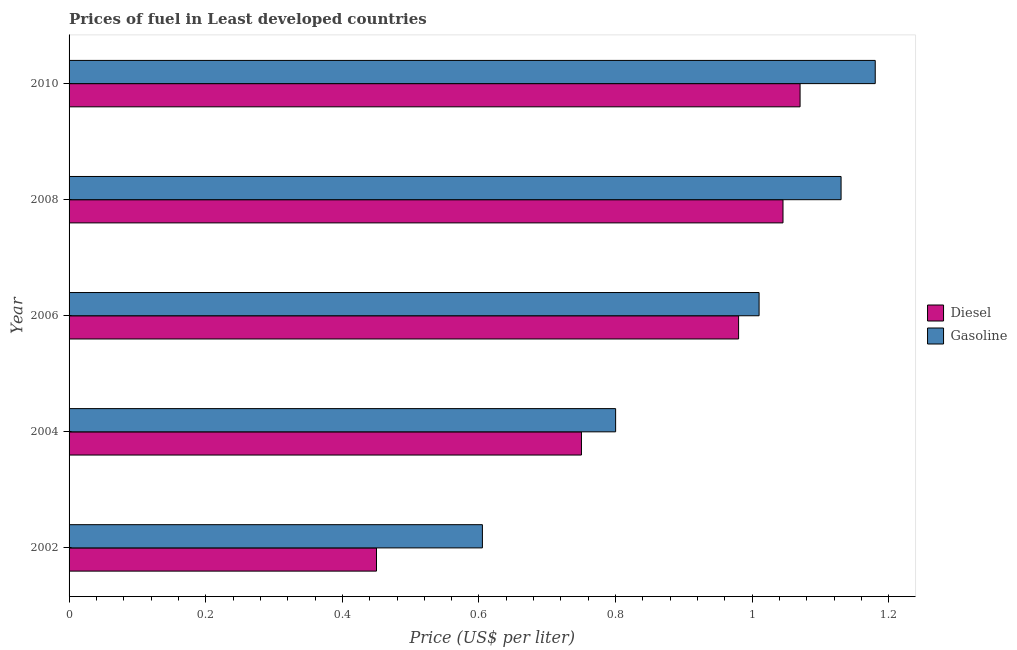How many different coloured bars are there?
Your answer should be compact. 2. How many groups of bars are there?
Your answer should be very brief. 5. How many bars are there on the 5th tick from the top?
Ensure brevity in your answer.  2. How many bars are there on the 5th tick from the bottom?
Your answer should be very brief. 2. In how many cases, is the number of bars for a given year not equal to the number of legend labels?
Make the answer very short. 0. What is the diesel price in 2006?
Provide a short and direct response. 0.98. Across all years, what is the maximum diesel price?
Provide a succinct answer. 1.07. Across all years, what is the minimum diesel price?
Ensure brevity in your answer.  0.45. In which year was the gasoline price maximum?
Your answer should be compact. 2010. In which year was the gasoline price minimum?
Give a very brief answer. 2002. What is the total gasoline price in the graph?
Your answer should be compact. 4.72. What is the difference between the gasoline price in 2004 and that in 2008?
Provide a succinct answer. -0.33. What is the difference between the diesel price in 2006 and the gasoline price in 2008?
Offer a terse response. -0.15. What is the average diesel price per year?
Keep it short and to the point. 0.86. What is the ratio of the gasoline price in 2002 to that in 2006?
Make the answer very short. 0.6. Is the gasoline price in 2002 less than that in 2010?
Make the answer very short. Yes. Is the difference between the gasoline price in 2002 and 2008 greater than the difference between the diesel price in 2002 and 2008?
Your answer should be compact. Yes. What is the difference between the highest and the second highest diesel price?
Provide a short and direct response. 0.03. What is the difference between the highest and the lowest gasoline price?
Make the answer very short. 0.57. Is the sum of the gasoline price in 2002 and 2004 greater than the maximum diesel price across all years?
Your response must be concise. Yes. What does the 1st bar from the top in 2004 represents?
Your answer should be compact. Gasoline. What does the 2nd bar from the bottom in 2006 represents?
Make the answer very short. Gasoline. Are all the bars in the graph horizontal?
Offer a very short reply. Yes. How many years are there in the graph?
Keep it short and to the point. 5. Are the values on the major ticks of X-axis written in scientific E-notation?
Give a very brief answer. No. What is the title of the graph?
Your response must be concise. Prices of fuel in Least developed countries. What is the label or title of the X-axis?
Your answer should be compact. Price (US$ per liter). What is the Price (US$ per liter) of Diesel in 2002?
Ensure brevity in your answer.  0.45. What is the Price (US$ per liter) in Gasoline in 2002?
Give a very brief answer. 0.6. What is the Price (US$ per liter) of Diesel in 2004?
Your answer should be compact. 0.75. What is the Price (US$ per liter) in Gasoline in 2004?
Make the answer very short. 0.8. What is the Price (US$ per liter) in Diesel in 2006?
Offer a very short reply. 0.98. What is the Price (US$ per liter) of Diesel in 2008?
Ensure brevity in your answer.  1.04. What is the Price (US$ per liter) in Gasoline in 2008?
Your answer should be compact. 1.13. What is the Price (US$ per liter) in Diesel in 2010?
Keep it short and to the point. 1.07. What is the Price (US$ per liter) of Gasoline in 2010?
Give a very brief answer. 1.18. Across all years, what is the maximum Price (US$ per liter) of Diesel?
Ensure brevity in your answer.  1.07. Across all years, what is the maximum Price (US$ per liter) of Gasoline?
Make the answer very short. 1.18. Across all years, what is the minimum Price (US$ per liter) in Diesel?
Offer a terse response. 0.45. Across all years, what is the minimum Price (US$ per liter) in Gasoline?
Make the answer very short. 0.6. What is the total Price (US$ per liter) in Diesel in the graph?
Your answer should be very brief. 4.29. What is the total Price (US$ per liter) in Gasoline in the graph?
Your answer should be compact. 4.72. What is the difference between the Price (US$ per liter) in Diesel in 2002 and that in 2004?
Give a very brief answer. -0.3. What is the difference between the Price (US$ per liter) of Gasoline in 2002 and that in 2004?
Your answer should be compact. -0.2. What is the difference between the Price (US$ per liter) in Diesel in 2002 and that in 2006?
Offer a terse response. -0.53. What is the difference between the Price (US$ per liter) in Gasoline in 2002 and that in 2006?
Make the answer very short. -0.41. What is the difference between the Price (US$ per liter) of Diesel in 2002 and that in 2008?
Make the answer very short. -0.59. What is the difference between the Price (US$ per liter) of Gasoline in 2002 and that in 2008?
Give a very brief answer. -0.53. What is the difference between the Price (US$ per liter) of Diesel in 2002 and that in 2010?
Make the answer very short. -0.62. What is the difference between the Price (US$ per liter) in Gasoline in 2002 and that in 2010?
Provide a short and direct response. -0.57. What is the difference between the Price (US$ per liter) in Diesel in 2004 and that in 2006?
Your answer should be compact. -0.23. What is the difference between the Price (US$ per liter) of Gasoline in 2004 and that in 2006?
Offer a very short reply. -0.21. What is the difference between the Price (US$ per liter) in Diesel in 2004 and that in 2008?
Provide a short and direct response. -0.29. What is the difference between the Price (US$ per liter) of Gasoline in 2004 and that in 2008?
Give a very brief answer. -0.33. What is the difference between the Price (US$ per liter) in Diesel in 2004 and that in 2010?
Your answer should be compact. -0.32. What is the difference between the Price (US$ per liter) in Gasoline in 2004 and that in 2010?
Your answer should be very brief. -0.38. What is the difference between the Price (US$ per liter) of Diesel in 2006 and that in 2008?
Your answer should be very brief. -0.07. What is the difference between the Price (US$ per liter) of Gasoline in 2006 and that in 2008?
Your answer should be very brief. -0.12. What is the difference between the Price (US$ per liter) in Diesel in 2006 and that in 2010?
Offer a very short reply. -0.09. What is the difference between the Price (US$ per liter) in Gasoline in 2006 and that in 2010?
Keep it short and to the point. -0.17. What is the difference between the Price (US$ per liter) in Diesel in 2008 and that in 2010?
Your response must be concise. -0.03. What is the difference between the Price (US$ per liter) of Gasoline in 2008 and that in 2010?
Ensure brevity in your answer.  -0.05. What is the difference between the Price (US$ per liter) in Diesel in 2002 and the Price (US$ per liter) in Gasoline in 2004?
Your response must be concise. -0.35. What is the difference between the Price (US$ per liter) in Diesel in 2002 and the Price (US$ per liter) in Gasoline in 2006?
Offer a terse response. -0.56. What is the difference between the Price (US$ per liter) of Diesel in 2002 and the Price (US$ per liter) of Gasoline in 2008?
Your answer should be very brief. -0.68. What is the difference between the Price (US$ per liter) in Diesel in 2002 and the Price (US$ per liter) in Gasoline in 2010?
Keep it short and to the point. -0.73. What is the difference between the Price (US$ per liter) in Diesel in 2004 and the Price (US$ per liter) in Gasoline in 2006?
Give a very brief answer. -0.26. What is the difference between the Price (US$ per liter) in Diesel in 2004 and the Price (US$ per liter) in Gasoline in 2008?
Your response must be concise. -0.38. What is the difference between the Price (US$ per liter) in Diesel in 2004 and the Price (US$ per liter) in Gasoline in 2010?
Give a very brief answer. -0.43. What is the difference between the Price (US$ per liter) in Diesel in 2006 and the Price (US$ per liter) in Gasoline in 2008?
Provide a short and direct response. -0.15. What is the difference between the Price (US$ per liter) in Diesel in 2008 and the Price (US$ per liter) in Gasoline in 2010?
Your answer should be compact. -0.14. What is the average Price (US$ per liter) of Diesel per year?
Keep it short and to the point. 0.86. What is the average Price (US$ per liter) in Gasoline per year?
Your response must be concise. 0.94. In the year 2002, what is the difference between the Price (US$ per liter) in Diesel and Price (US$ per liter) in Gasoline?
Ensure brevity in your answer.  -0.15. In the year 2004, what is the difference between the Price (US$ per liter) in Diesel and Price (US$ per liter) in Gasoline?
Your answer should be compact. -0.05. In the year 2006, what is the difference between the Price (US$ per liter) of Diesel and Price (US$ per liter) of Gasoline?
Give a very brief answer. -0.03. In the year 2008, what is the difference between the Price (US$ per liter) in Diesel and Price (US$ per liter) in Gasoline?
Keep it short and to the point. -0.09. In the year 2010, what is the difference between the Price (US$ per liter) of Diesel and Price (US$ per liter) of Gasoline?
Give a very brief answer. -0.11. What is the ratio of the Price (US$ per liter) of Gasoline in 2002 to that in 2004?
Your answer should be very brief. 0.76. What is the ratio of the Price (US$ per liter) in Diesel in 2002 to that in 2006?
Keep it short and to the point. 0.46. What is the ratio of the Price (US$ per liter) in Gasoline in 2002 to that in 2006?
Provide a succinct answer. 0.6. What is the ratio of the Price (US$ per liter) of Diesel in 2002 to that in 2008?
Your answer should be compact. 0.43. What is the ratio of the Price (US$ per liter) of Gasoline in 2002 to that in 2008?
Your response must be concise. 0.54. What is the ratio of the Price (US$ per liter) in Diesel in 2002 to that in 2010?
Offer a terse response. 0.42. What is the ratio of the Price (US$ per liter) in Gasoline in 2002 to that in 2010?
Offer a very short reply. 0.51. What is the ratio of the Price (US$ per liter) in Diesel in 2004 to that in 2006?
Ensure brevity in your answer.  0.77. What is the ratio of the Price (US$ per liter) in Gasoline in 2004 to that in 2006?
Make the answer very short. 0.79. What is the ratio of the Price (US$ per liter) in Diesel in 2004 to that in 2008?
Your response must be concise. 0.72. What is the ratio of the Price (US$ per liter) in Gasoline in 2004 to that in 2008?
Your response must be concise. 0.71. What is the ratio of the Price (US$ per liter) of Diesel in 2004 to that in 2010?
Give a very brief answer. 0.7. What is the ratio of the Price (US$ per liter) in Gasoline in 2004 to that in 2010?
Your answer should be very brief. 0.68. What is the ratio of the Price (US$ per liter) of Diesel in 2006 to that in 2008?
Ensure brevity in your answer.  0.94. What is the ratio of the Price (US$ per liter) of Gasoline in 2006 to that in 2008?
Your answer should be very brief. 0.89. What is the ratio of the Price (US$ per liter) of Diesel in 2006 to that in 2010?
Your response must be concise. 0.92. What is the ratio of the Price (US$ per liter) in Gasoline in 2006 to that in 2010?
Offer a very short reply. 0.86. What is the ratio of the Price (US$ per liter) of Diesel in 2008 to that in 2010?
Ensure brevity in your answer.  0.98. What is the ratio of the Price (US$ per liter) of Gasoline in 2008 to that in 2010?
Provide a succinct answer. 0.96. What is the difference between the highest and the second highest Price (US$ per liter) of Diesel?
Your answer should be very brief. 0.03. What is the difference between the highest and the lowest Price (US$ per liter) of Diesel?
Offer a terse response. 0.62. What is the difference between the highest and the lowest Price (US$ per liter) in Gasoline?
Your answer should be compact. 0.57. 